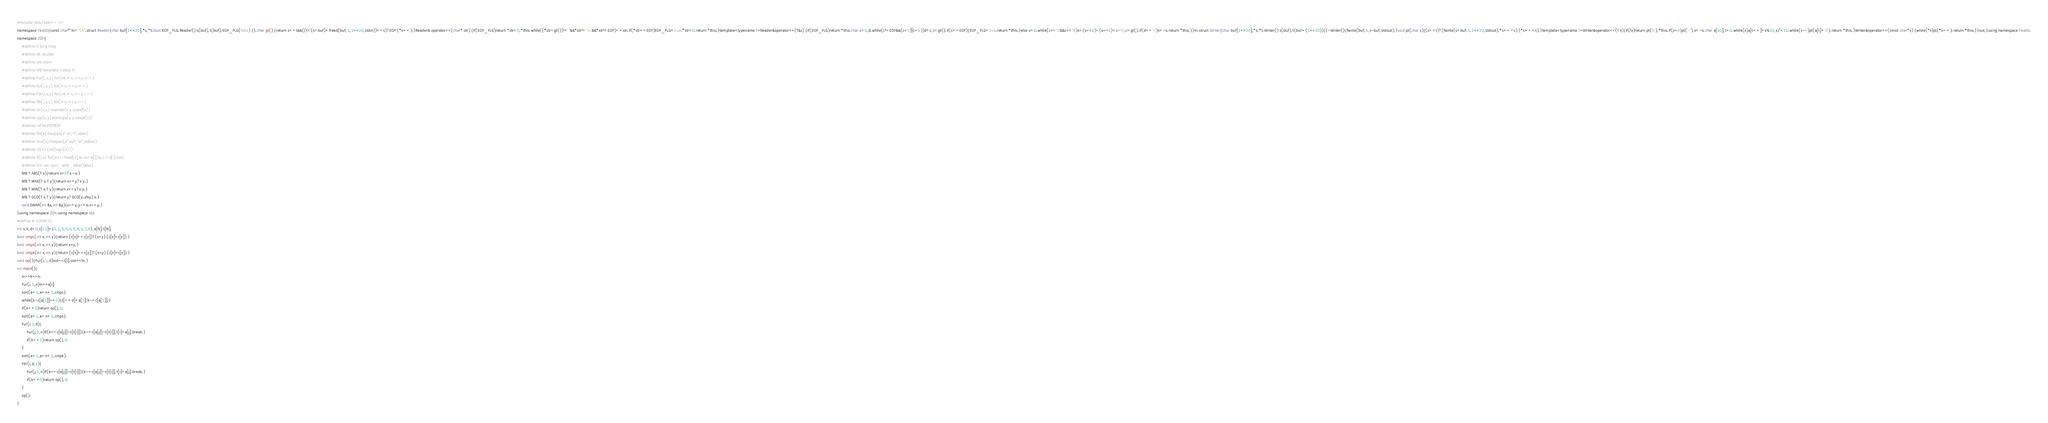<code> <loc_0><loc_0><loc_500><loc_500><_C++_>#include<bits/stdc++.h>
namespace FastIO{const char* ln="\n";struct Reader{char buf[1<<20],*s,*t;bool EOF_FLG;Reader():s(buf),t(buf),EOF_FLG(false) {};char gt() {return s==t&&((t=(s=buf)+fread(buf,1,1<<20,stdin))==s)?EOF:(*s++);}Reader& operator>>(char* str) {if(EOF_FLG)return *str=0,*this;while((*str=gt())!=' '&&*str!='\n'&&*str!=EOF)++str;if(*str==EOF)EOF_FLG=true;*str=0;return *this;}template<typename T>Reader&operator>>(T&x) {if(EOF_FLG)return *this;char c=0,d;while(c!=EOF&&(c<'0'||c>'9'))d=c,c=gt();if(c==EOF){EOF_FLG=true;return *this;}else x=0;while(c>='0'&&c<='9')x=(x<<3)+(x<<1)+c-'0',c=gt();if(d=='-')x=-x;return *this;}}in;struct Writer{char buf[1<<20],*s,*t;Writer():s(buf),t(buf+(1<<20)){}~Writer(){fwrite(buf,1,s-buf,stdout);}void pt(char c){(s==t)?(fwrite(s=buf,1,1<<20,stdout),*s++=c):(*s++=c);}template<typename T>Writer&operator<<(T x){if(!x)return pt('0'),*this;if(x<0)pt('-'),x=-x;char a[40],t=0;while(x)a[t++]=x%10,x/=10;while(t--)pt(a[t]+'0');return *this;}Writer&operator<<(const char*s) {while(*s)pt(*s++);return *this;}}out;}using namespace FastIO;
namespace ZDY{
    #define ll long long
    #define db double
    #define sht short
    #define MB template <class T>
    #define Fur(i,x,y) for(int i=x;i<=y;i++)
    #define fur(i,x,y) for(i=x;i<=y;i++)
    #define Fdr(i,x,y) for(int i=x;i>=y;i--)
    #define fdr(i,x,y) for(i=x;i>=y;i--)
    #define clr(x,y) memset(x,y,sizeof(x))
    #define cpy(x,y) memcpy(x,y,sizeof(x))
    #define inf 0x3f3f3f3f
    #define fin(s) freopen(s".in","r",stdin)
    #define fout(s) freopen(s".out","w",stdout)
    #define l2(n) (int(log2(n)))
    #define fl(i,x) for(int i=head[x],to;to=e[i].to,i;i=e[i].nxt)
    #define fcin ios::sync_with_stdio(false)
    MB T ABS(T x){return x>0?x:-x;}
    MB T MAX(T x,T y){return x>=y?x:y;}
    MB T MIN(T x,T y){return x<=y?x:y;}
    MB T GCD(T x,T y){return y?GCD(y,x%y):x;}
    void SWAP(int &x,int &y){x^=y;y^=x;x^=y;}
}using namespace ZDY;using namespace std;
#define N 1000011
int n,k,d=0,c[11]={0,2,5,5,4,5,6,3,7,6},a[N],t[N];
bool cmpc(int x,int y){return (c[x]==c[y])?(x>y):(c[x]<c[y]);}
bool cmps(int x,int y){return x>y;}
bool cmpk(int x,int y){return (c[x]==c[y])?(x>y):(c[x]>c[y]);}
void op(){Fur(i,1,d)out<<t[i];out<<ln;}
int main(){
    in>>k>>n;
    Fur(i,1,n)in>>a[i];
    sort(a+1,a+n+1,cmpc);
    while(k-c[a[1]]>=0){t[++d]=a[1];k-=c[a[1]];}
    if(k==0)return op(),0;
    sort(a+1,a+n+1,cmps);
    Fur(i,1,d){
        Fur(j,1,n)if(k>=c[a[j]]-c[t[i]]){k-=c[a[j]]-c[t[i]],t[i]=a[j];break;}
        if(k==0)return op(),0;
    }
    sort(a+1,a+n+1,cmpk);
    Fdr(i,d,1){
        Fur(j,1,n)if(k>=c[a[j]]-c[t[i]]){k-=c[a[j]]-c[t[i]],t[i]=a[j];break;}
        if(k==0)return op(),0;
    }
    op();
}</code> 